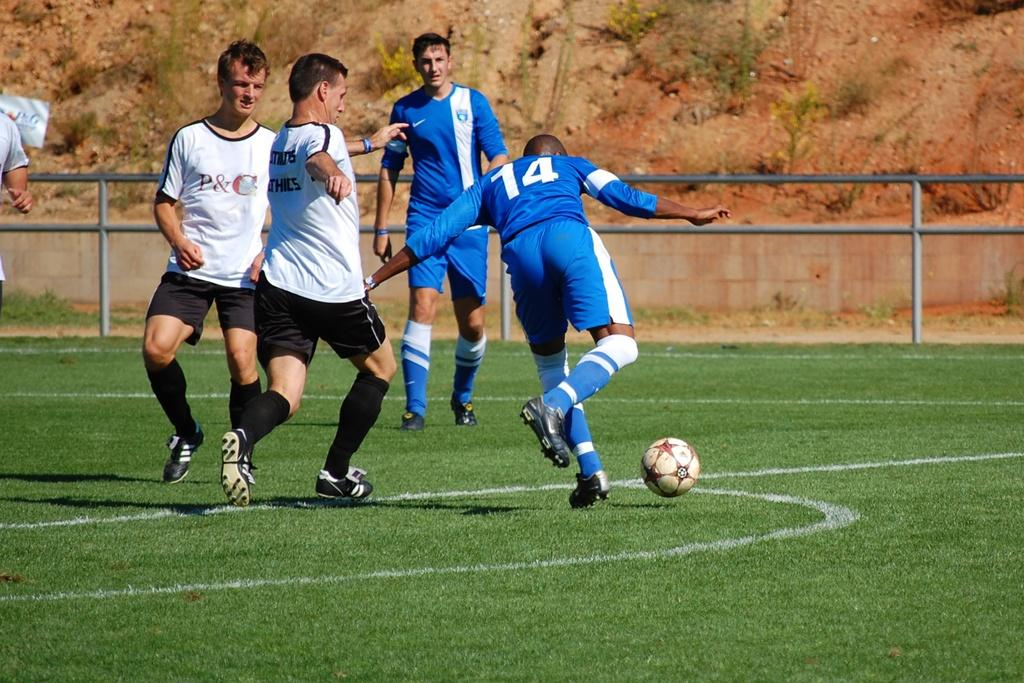<image>
Present a compact description of the photo's key features. A soccer player wears a t-shirt with P & C on it as he plays soccer with his teammates and opponents. 